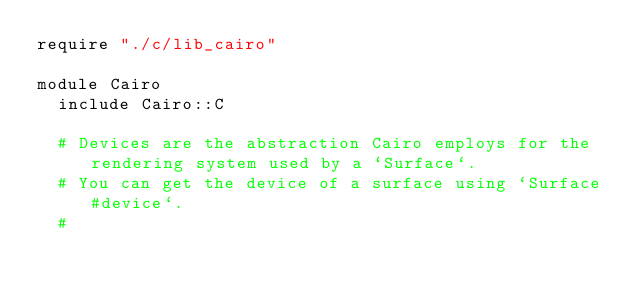<code> <loc_0><loc_0><loc_500><loc_500><_Crystal_>require "./c/lib_cairo"

module Cairo
  include Cairo::C

  # Devices are the abstraction Cairo employs for the rendering system used by a `Surface`.
  # You can get the device of a surface using `Surface#device`.
  #</code> 